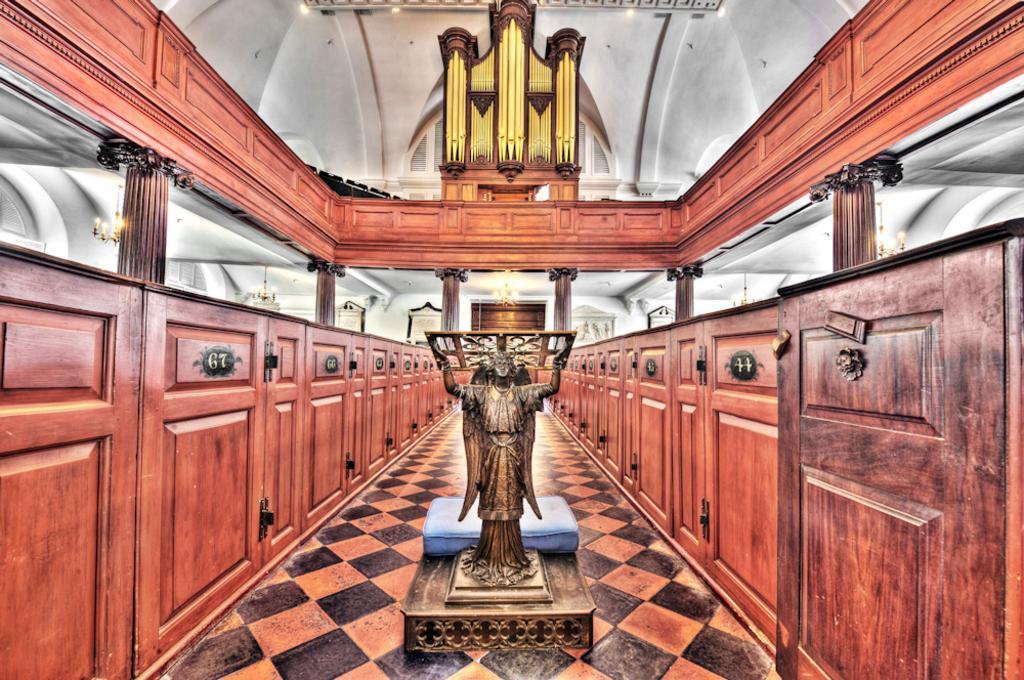Could you give a brief overview of what you see in this image? In this picture there is a statue and there are few wooden cupboards on either sides of it and there are some other objects in the background. 